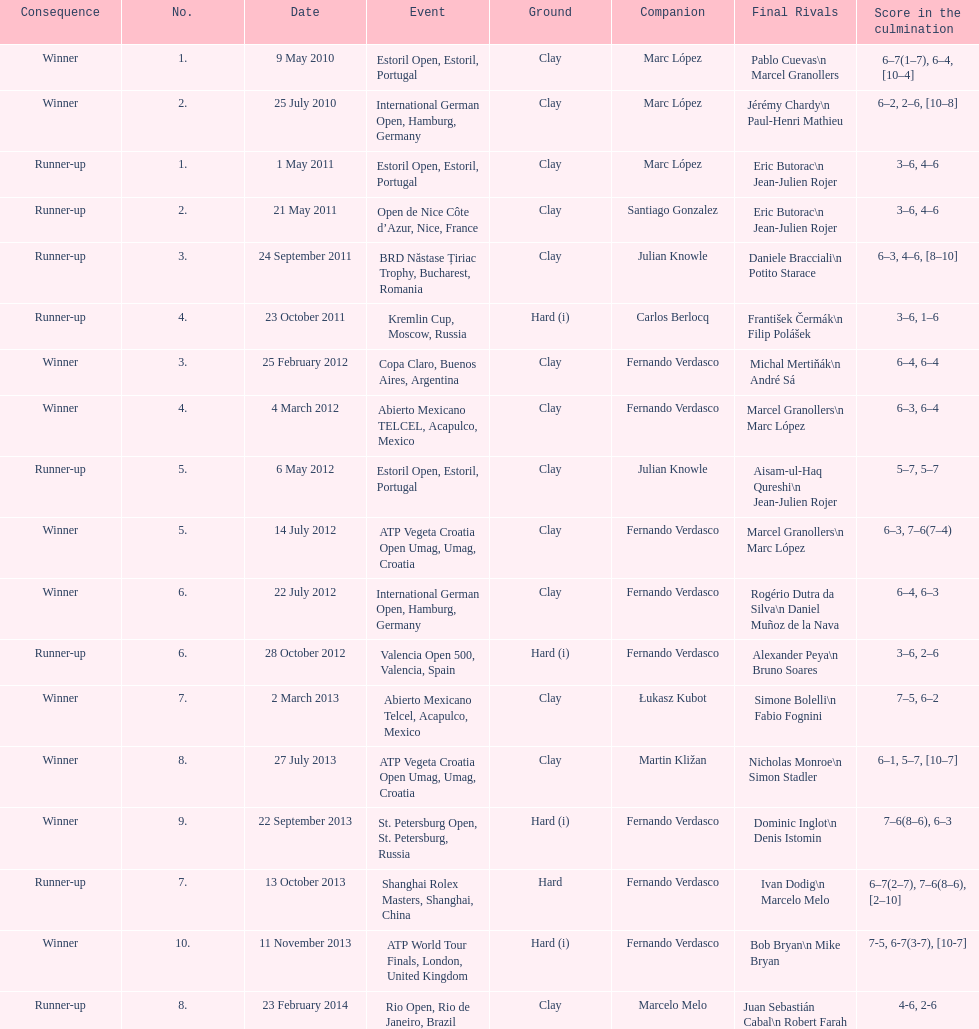Can you give me this table as a dict? {'header': ['Consequence', 'No.', 'Date', 'Event', 'Ground', 'Companion', 'Final Rivals', 'Score in the culmination'], 'rows': [['Winner', '1.', '9 May 2010', 'Estoril Open, Estoril, Portugal', 'Clay', 'Marc López', 'Pablo Cuevas\\n Marcel Granollers', '6–7(1–7), 6–4, [10–4]'], ['Winner', '2.', '25 July 2010', 'International German Open, Hamburg, Germany', 'Clay', 'Marc López', 'Jérémy Chardy\\n Paul-Henri Mathieu', '6–2, 2–6, [10–8]'], ['Runner-up', '1.', '1 May 2011', 'Estoril Open, Estoril, Portugal', 'Clay', 'Marc López', 'Eric Butorac\\n Jean-Julien Rojer', '3–6, 4–6'], ['Runner-up', '2.', '21 May 2011', 'Open de Nice Côte d’Azur, Nice, France', 'Clay', 'Santiago Gonzalez', 'Eric Butorac\\n Jean-Julien Rojer', '3–6, 4–6'], ['Runner-up', '3.', '24 September 2011', 'BRD Năstase Țiriac Trophy, Bucharest, Romania', 'Clay', 'Julian Knowle', 'Daniele Bracciali\\n Potito Starace', '6–3, 4–6, [8–10]'], ['Runner-up', '4.', '23 October 2011', 'Kremlin Cup, Moscow, Russia', 'Hard (i)', 'Carlos Berlocq', 'František Čermák\\n Filip Polášek', '3–6, 1–6'], ['Winner', '3.', '25 February 2012', 'Copa Claro, Buenos Aires, Argentina', 'Clay', 'Fernando Verdasco', 'Michal Mertiňák\\n André Sá', '6–4, 6–4'], ['Winner', '4.', '4 March 2012', 'Abierto Mexicano TELCEL, Acapulco, Mexico', 'Clay', 'Fernando Verdasco', 'Marcel Granollers\\n Marc López', '6–3, 6–4'], ['Runner-up', '5.', '6 May 2012', 'Estoril Open, Estoril, Portugal', 'Clay', 'Julian Knowle', 'Aisam-ul-Haq Qureshi\\n Jean-Julien Rojer', '5–7, 5–7'], ['Winner', '5.', '14 July 2012', 'ATP Vegeta Croatia Open Umag, Umag, Croatia', 'Clay', 'Fernando Verdasco', 'Marcel Granollers\\n Marc López', '6–3, 7–6(7–4)'], ['Winner', '6.', '22 July 2012', 'International German Open, Hamburg, Germany', 'Clay', 'Fernando Verdasco', 'Rogério Dutra da Silva\\n Daniel Muñoz de la Nava', '6–4, 6–3'], ['Runner-up', '6.', '28 October 2012', 'Valencia Open 500, Valencia, Spain', 'Hard (i)', 'Fernando Verdasco', 'Alexander Peya\\n Bruno Soares', '3–6, 2–6'], ['Winner', '7.', '2 March 2013', 'Abierto Mexicano Telcel, Acapulco, Mexico', 'Clay', 'Łukasz Kubot', 'Simone Bolelli\\n Fabio Fognini', '7–5, 6–2'], ['Winner', '8.', '27 July 2013', 'ATP Vegeta Croatia Open Umag, Umag, Croatia', 'Clay', 'Martin Kližan', 'Nicholas Monroe\\n Simon Stadler', '6–1, 5–7, [10–7]'], ['Winner', '9.', '22 September 2013', 'St. Petersburg Open, St. Petersburg, Russia', 'Hard (i)', 'Fernando Verdasco', 'Dominic Inglot\\n Denis Istomin', '7–6(8–6), 6–3'], ['Runner-up', '7.', '13 October 2013', 'Shanghai Rolex Masters, Shanghai, China', 'Hard', 'Fernando Verdasco', 'Ivan Dodig\\n Marcelo Melo', '6–7(2–7), 7–6(8–6), [2–10]'], ['Winner', '10.', '11 November 2013', 'ATP World Tour Finals, London, United Kingdom', 'Hard (i)', 'Fernando Verdasco', 'Bob Bryan\\n Mike Bryan', '7-5, 6-7(3-7), [10-7]'], ['Runner-up', '8.', '23 February 2014', 'Rio Open, Rio de Janeiro, Brazil', 'Clay', 'Marcelo Melo', 'Juan Sebastián Cabal\\n Robert Farah', '4-6, 2-6']]} What is the number of times a hard surface was used? 5. 